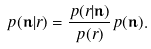Convert formula to latex. <formula><loc_0><loc_0><loc_500><loc_500>p ( \mathbf n | r ) = \frac { p ( r | \mathbf n ) } { p ( r ) } p ( \mathbf n ) .</formula> 